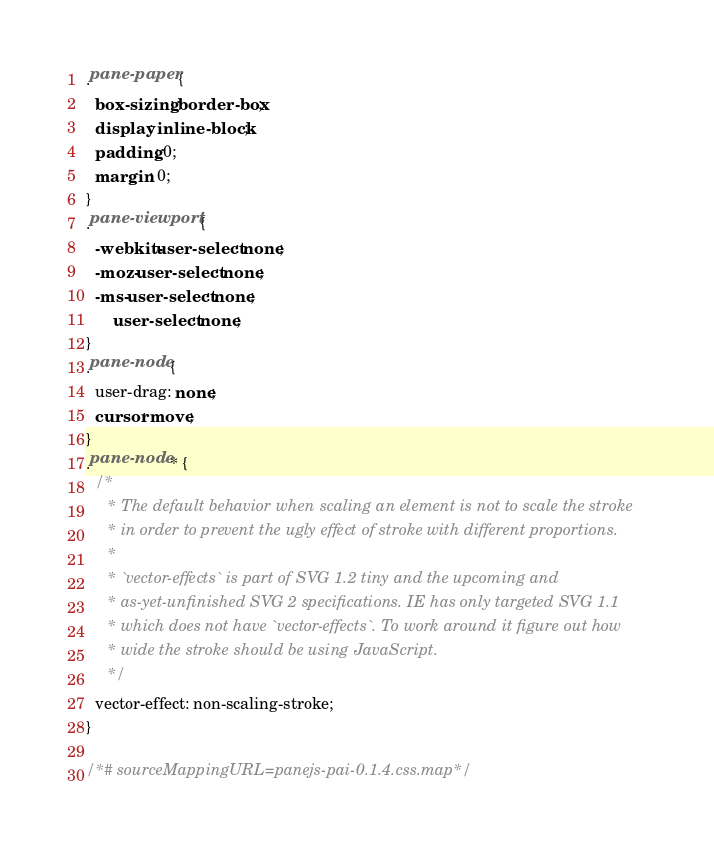Convert code to text. <code><loc_0><loc_0><loc_500><loc_500><_CSS_>.pane-paper {
  box-sizing: border-box;
  display: inline-block;
  padding: 0;
  margin: 0;
}
.pane-viewport {
  -webkit-user-select: none;
  -moz-user-select: none;
  -ms-user-select: none;
      user-select: none;
}
.pane-node {
  user-drag: none;
  cursor: move;
}
.pane-node * {
  /*
     * The default behavior when scaling an element is not to scale the stroke
     * in order to prevent the ugly effect of stroke with different proportions.
     *
     * `vector-effects` is part of SVG 1.2 tiny and the upcoming and
     * as-yet-unfinished SVG 2 specifications. IE has only targeted SVG 1.1
     * which does not have `vector-effects`. To work around it figure out how
     * wide the stroke should be using JavaScript.
     */
  vector-effect: non-scaling-stroke;
}

/*# sourceMappingURL=panejs-pai-0.1.4.css.map*/</code> 